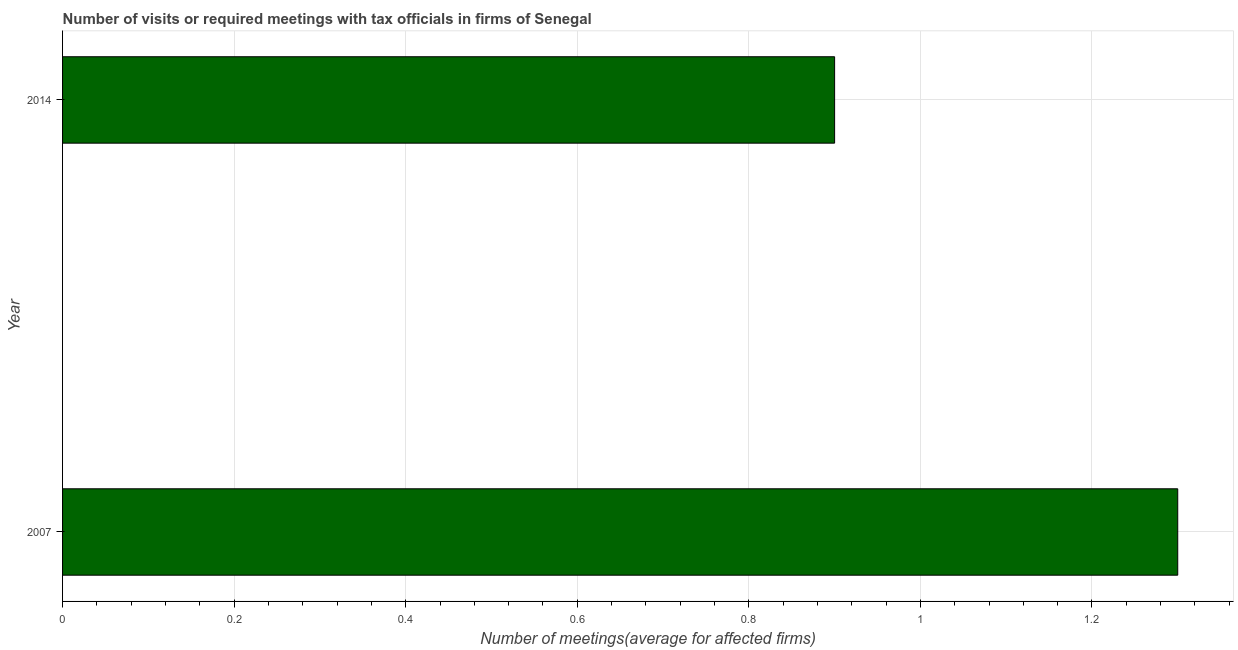Does the graph contain grids?
Your answer should be very brief. Yes. What is the title of the graph?
Offer a very short reply. Number of visits or required meetings with tax officials in firms of Senegal. What is the label or title of the X-axis?
Your answer should be very brief. Number of meetings(average for affected firms). Across all years, what is the minimum number of required meetings with tax officials?
Make the answer very short. 0.9. In which year was the number of required meetings with tax officials maximum?
Keep it short and to the point. 2007. In which year was the number of required meetings with tax officials minimum?
Your answer should be very brief. 2014. What is the difference between the number of required meetings with tax officials in 2007 and 2014?
Offer a very short reply. 0.4. What is the average number of required meetings with tax officials per year?
Provide a succinct answer. 1.1. What is the median number of required meetings with tax officials?
Offer a terse response. 1.1. Do a majority of the years between 2014 and 2007 (inclusive) have number of required meetings with tax officials greater than 1.28 ?
Provide a short and direct response. No. What is the ratio of the number of required meetings with tax officials in 2007 to that in 2014?
Ensure brevity in your answer.  1.44. Is the number of required meetings with tax officials in 2007 less than that in 2014?
Give a very brief answer. No. In how many years, is the number of required meetings with tax officials greater than the average number of required meetings with tax officials taken over all years?
Offer a terse response. 1. Are all the bars in the graph horizontal?
Provide a short and direct response. Yes. Are the values on the major ticks of X-axis written in scientific E-notation?
Ensure brevity in your answer.  No. What is the Number of meetings(average for affected firms) in 2014?
Your answer should be very brief. 0.9. What is the ratio of the Number of meetings(average for affected firms) in 2007 to that in 2014?
Offer a terse response. 1.44. 